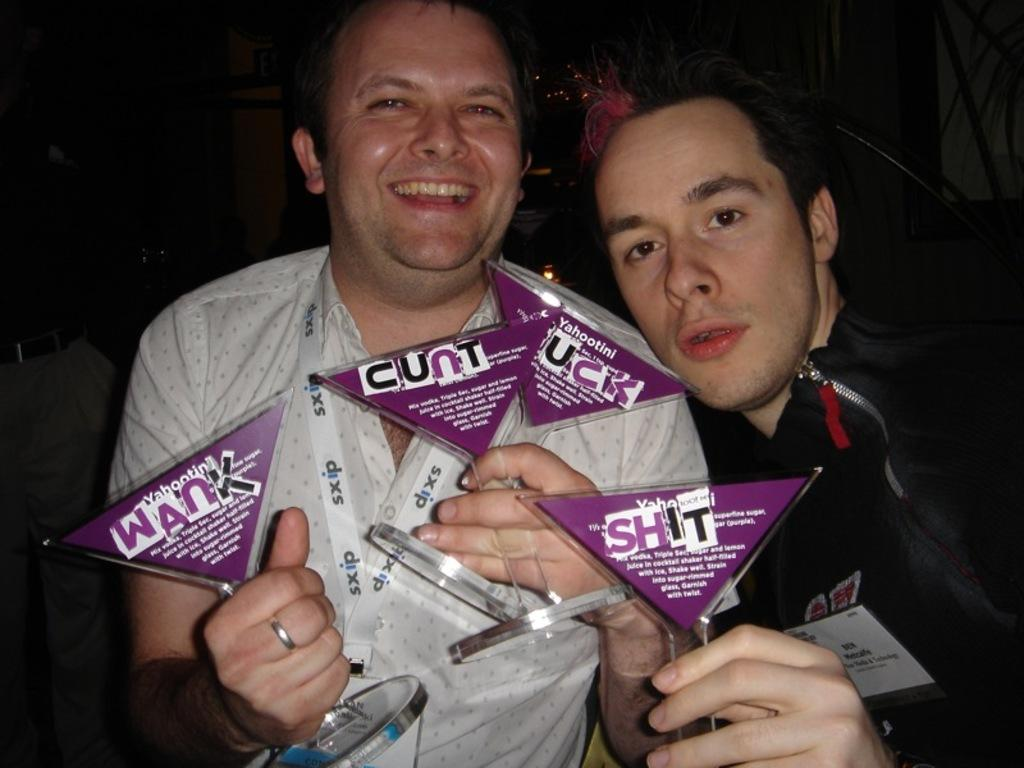How many people are in the image? There are two persons in the image. What are the persons holding in their hands? The persons are holding objects in their hands. Can you describe any other objects present in the image? There are other objects present in the background of the image. What type of soup is being served by the pig in the image? There is no pig present in the image, nor is there any soup being served. 